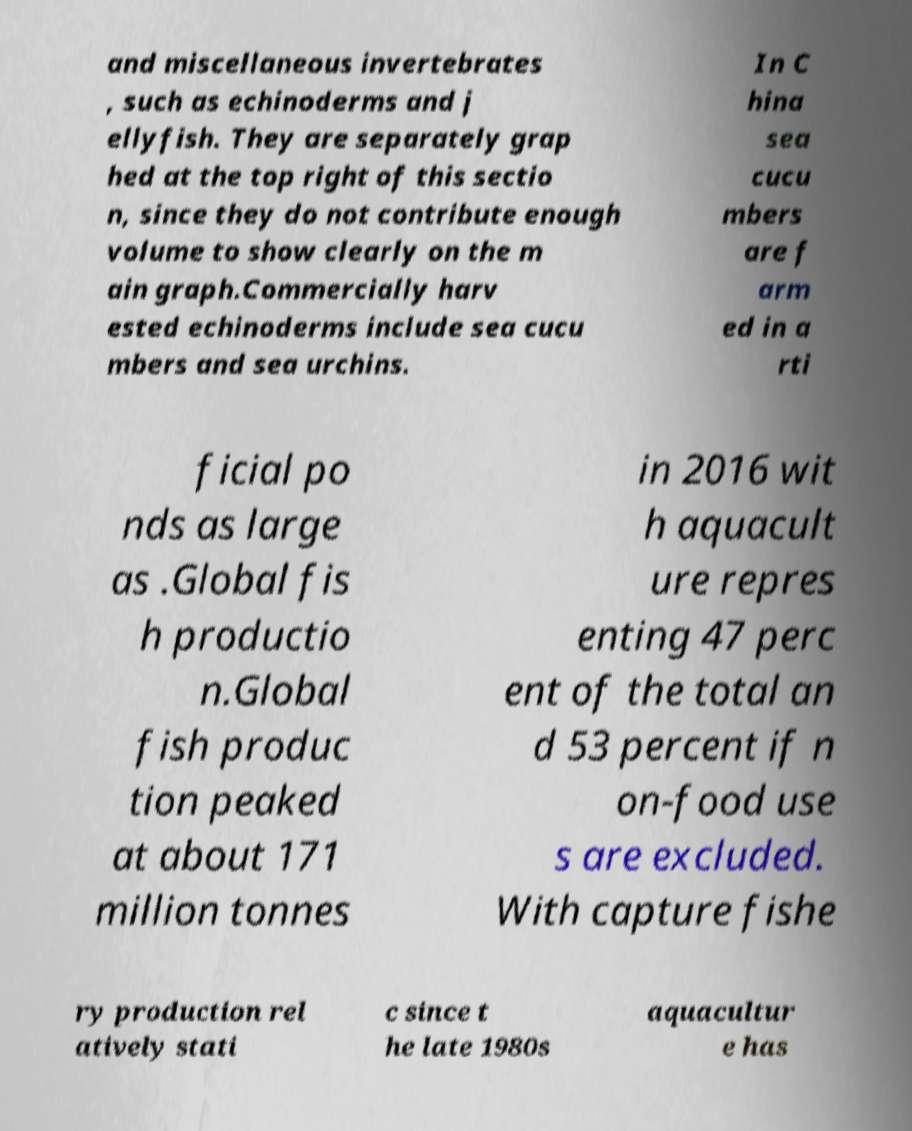For documentation purposes, I need the text within this image transcribed. Could you provide that? and miscellaneous invertebrates , such as echinoderms and j ellyfish. They are separately grap hed at the top right of this sectio n, since they do not contribute enough volume to show clearly on the m ain graph.Commercially harv ested echinoderms include sea cucu mbers and sea urchins. In C hina sea cucu mbers are f arm ed in a rti ficial po nds as large as .Global fis h productio n.Global fish produc tion peaked at about 171 million tonnes in 2016 wit h aquacult ure repres enting 47 perc ent of the total an d 53 percent if n on-food use s are excluded. With capture fishe ry production rel atively stati c since t he late 1980s aquacultur e has 